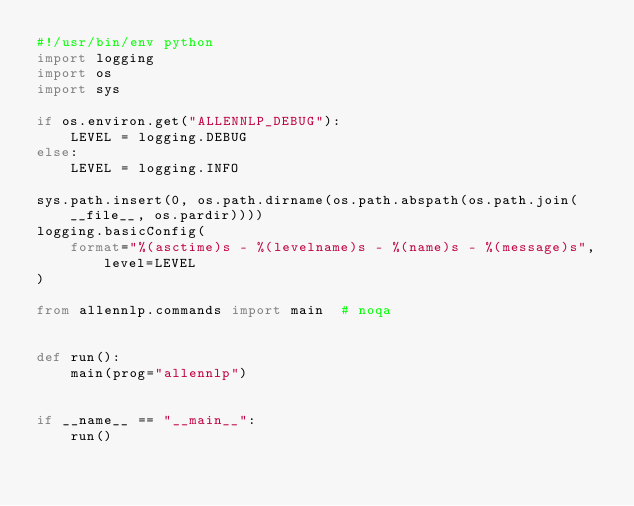<code> <loc_0><loc_0><loc_500><loc_500><_Python_>#!/usr/bin/env python
import logging
import os
import sys

if os.environ.get("ALLENNLP_DEBUG"):
    LEVEL = logging.DEBUG
else:
    LEVEL = logging.INFO

sys.path.insert(0, os.path.dirname(os.path.abspath(os.path.join(__file__, os.pardir))))
logging.basicConfig(
    format="%(asctime)s - %(levelname)s - %(name)s - %(message)s", level=LEVEL
)

from allennlp.commands import main  # noqa


def run():
    main(prog="allennlp")


if __name__ == "__main__":
    run()
</code> 